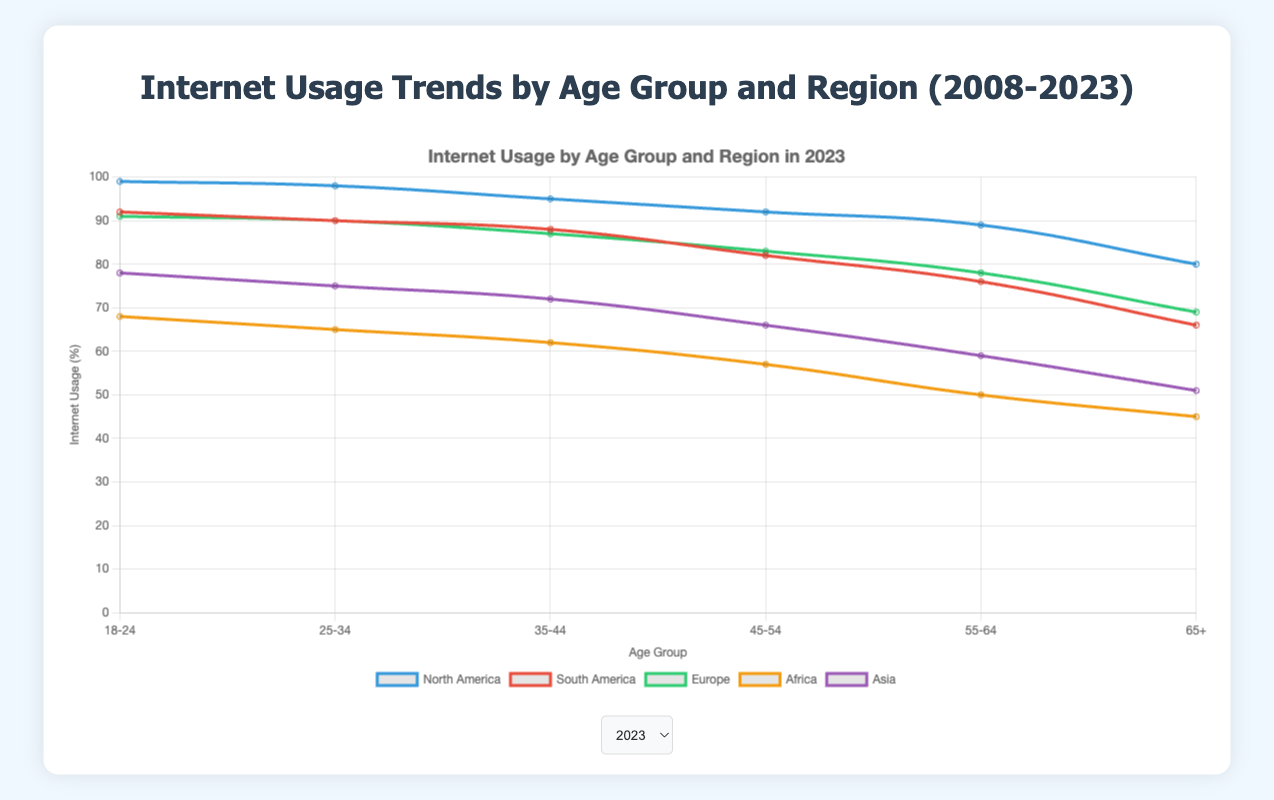What is the trend in internet usage among the 18-24 age group in North America from 2008 to 2023? To understand the trend, I will look at the values for the 18-24 age group in North America over the years 2008, 2013, 2018, and 2023. The values are 68%, 89%, 96%, and 99% respectively. This indicates a consistent increase in internet usage over time.
Answer: Consistent increase Which age group showed the greatest percentage increase in internet usage in Africa from 2008 to 2023? First, I will find the percentage usage for each age group in Africa for the years 2008 and 2023. For 18-24: 10% to 68%, 25-34: 9% to 65%, 35-44: 8% to 62%, 45-54: 7% to 57%, 55-64: 6% to 50%, and 65+: 4% to 45%. Next, I will calculate the increases: 58%, 56%, 54%, 50%, 44%, and 41% respectively. The highest increase is in the 18-24 age group with 58%.
Answer: 18-24 Compare the internet usage in Europe and Asia among the 45-54 age group in 2023. Which region has higher usage, and by how much? I will look at the internet usage statistics for Europe and Asia in the 45-54 age group for 2023. Europe has 83%, and Asia has 66%. Europe has higher usage. The difference is 83% - 66% = 17%.
Answer: Europe, by 17% What is the average internet usage for the 65+ age group across all regions in 2018? First, I will find the internet usage for the 65+ age group in 2018, which are: North America - 70%, South America - 55%, Europe - 58%, Africa - 32%, and Asia - 38%. Adding these together: 70 + 55 + 58 + 32 + 38 = 253. Then, I divide by the number of regions (5): 253 / 5 = 50.6%.
Answer: 50.6% Identify the year with the highest internet usage for the 25-34 age group in South America. Reviewing the internet usage for the 25-34 age group in South America: 48% (2008), 72% (2013), 83% (2018), and 90% (2023). The highest is in 2023 with 90%.
Answer: 2023 